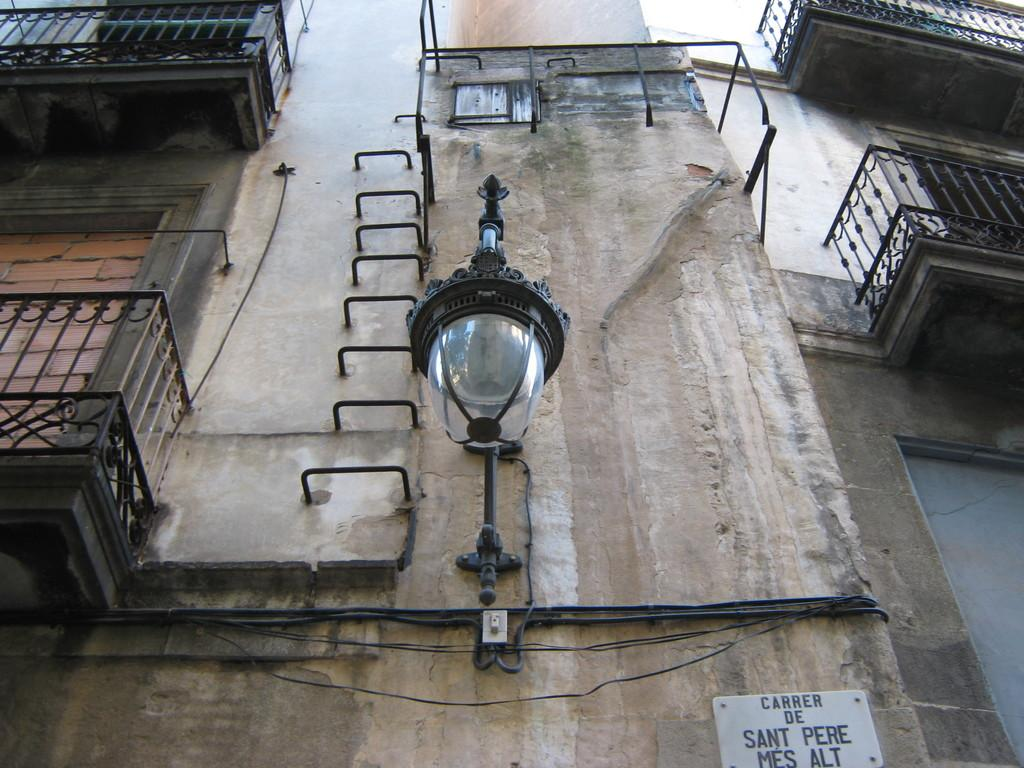What is the perspective of the image? The image is a backside view of a building. What architectural features can be seen on the building? There are balconies visible on the building. Are there any objects present in the image besides the building? Yes, there is a lamp in the image. What type of fuel is being used by the cat in the image? There is no cat present in the image, so the question about fuel is not applicable. 